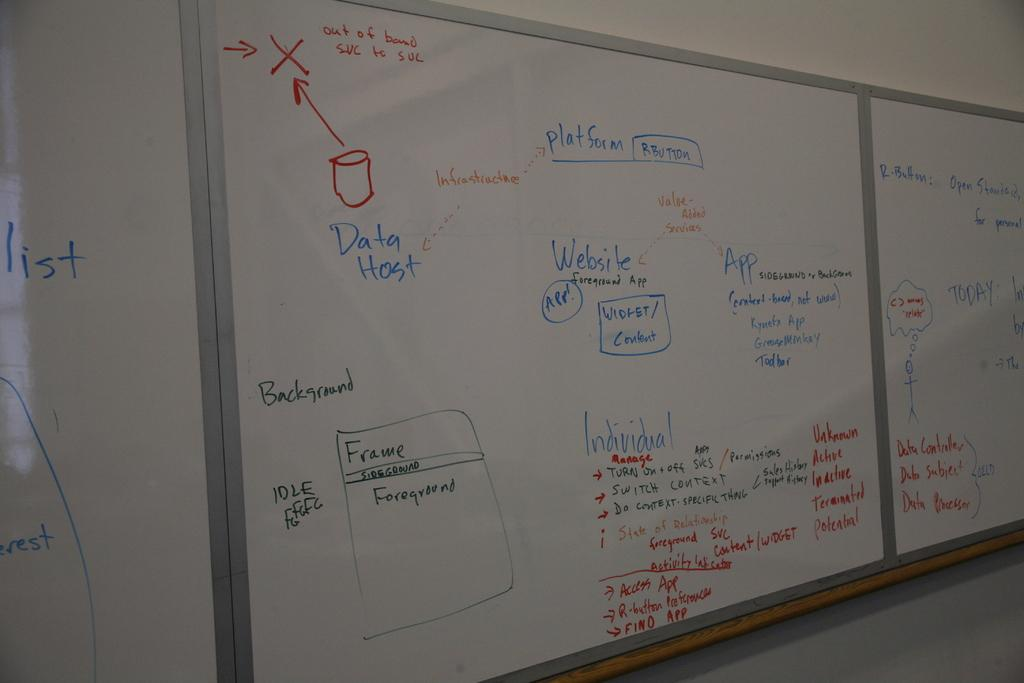<image>
Provide a brief description of the given image. several white boards are written on, as if for a class involving data hosting 